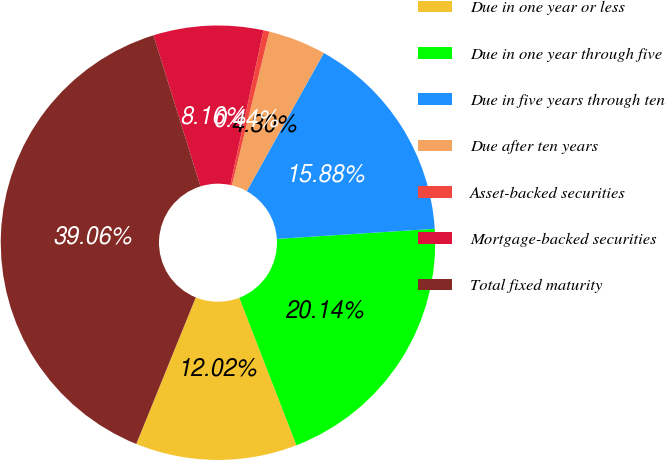<chart> <loc_0><loc_0><loc_500><loc_500><pie_chart><fcel>Due in one year or less<fcel>Due in one year through five<fcel>Due in five years through ten<fcel>Due after ten years<fcel>Asset-backed securities<fcel>Mortgage-backed securities<fcel>Total fixed maturity<nl><fcel>12.02%<fcel>20.14%<fcel>15.88%<fcel>4.3%<fcel>0.44%<fcel>8.16%<fcel>39.06%<nl></chart> 